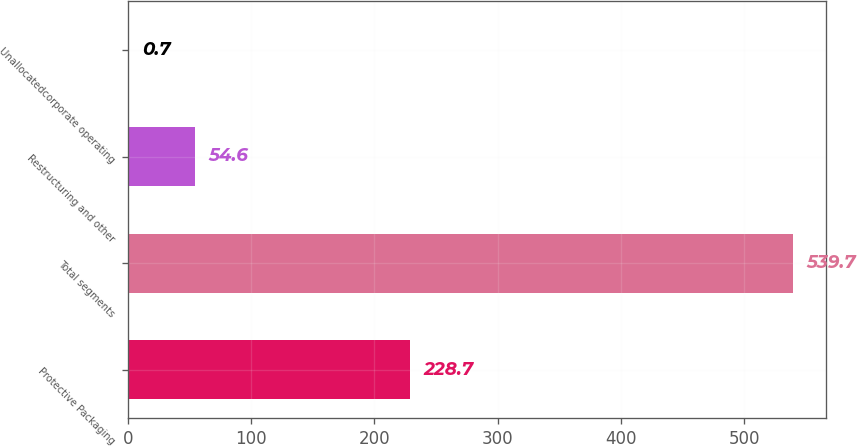Convert chart to OTSL. <chart><loc_0><loc_0><loc_500><loc_500><bar_chart><fcel>Protective Packaging<fcel>Total segments<fcel>Restructuring and other<fcel>Unallocatedcorporate operating<nl><fcel>228.7<fcel>539.7<fcel>54.6<fcel>0.7<nl></chart> 